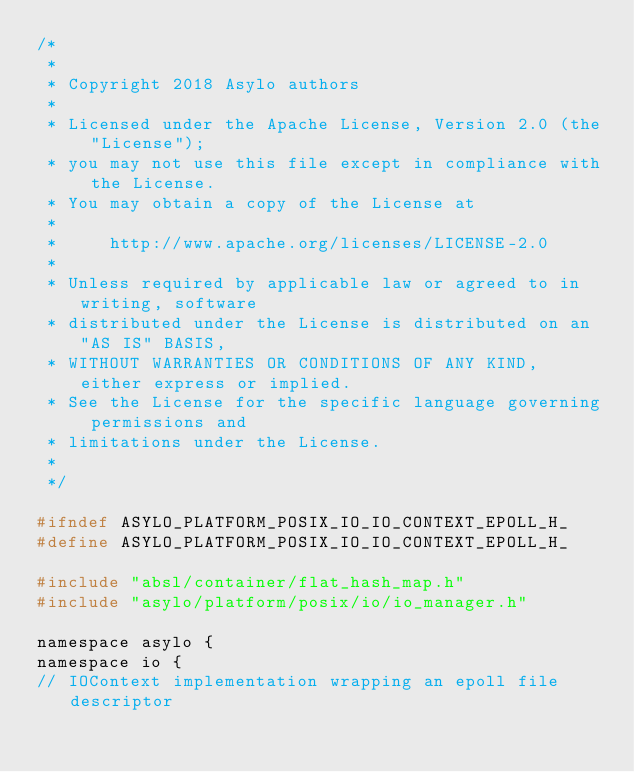<code> <loc_0><loc_0><loc_500><loc_500><_C_>/*
 *
 * Copyright 2018 Asylo authors
 *
 * Licensed under the Apache License, Version 2.0 (the "License");
 * you may not use this file except in compliance with the License.
 * You may obtain a copy of the License at
 *
 *     http://www.apache.org/licenses/LICENSE-2.0
 *
 * Unless required by applicable law or agreed to in writing, software
 * distributed under the License is distributed on an "AS IS" BASIS,
 * WITHOUT WARRANTIES OR CONDITIONS OF ANY KIND, either express or implied.
 * See the License for the specific language governing permissions and
 * limitations under the License.
 *
 */

#ifndef ASYLO_PLATFORM_POSIX_IO_IO_CONTEXT_EPOLL_H_
#define ASYLO_PLATFORM_POSIX_IO_IO_CONTEXT_EPOLL_H_

#include "absl/container/flat_hash_map.h"
#include "asylo/platform/posix/io/io_manager.h"

namespace asylo {
namespace io {
// IOContext implementation wrapping an epoll file descriptor</code> 